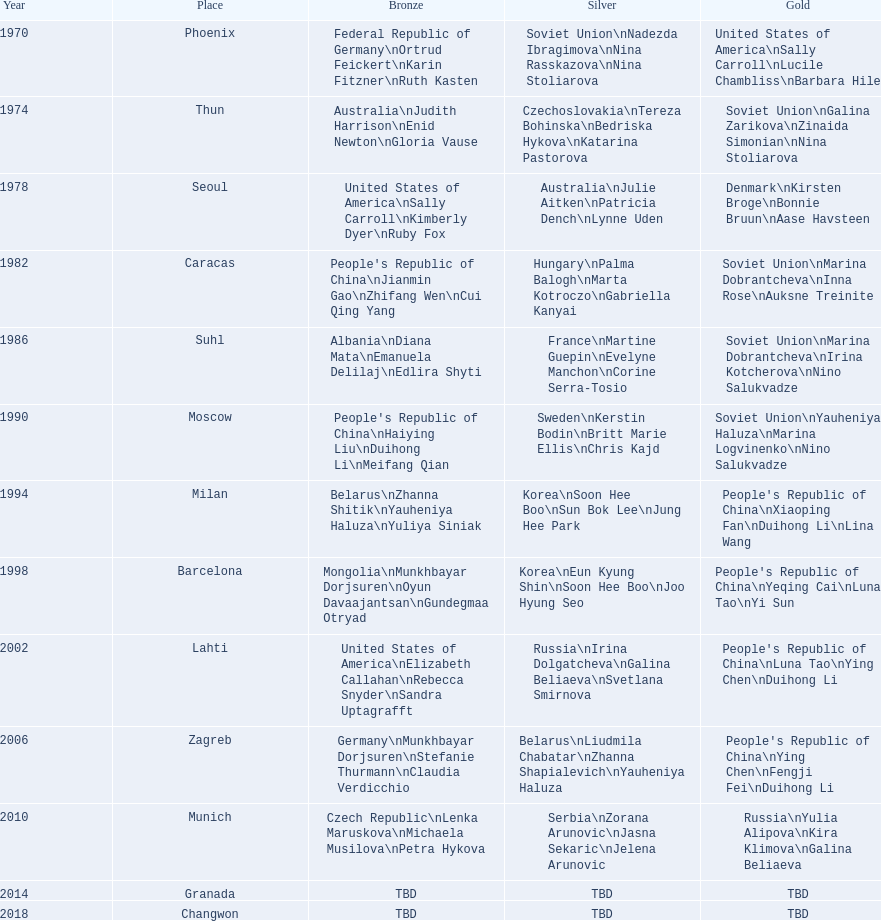What are the total number of times the soviet union is listed under the gold column? 4. 